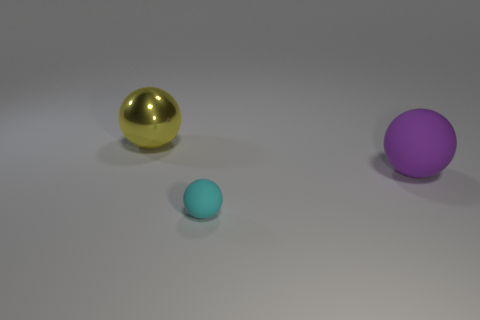The large metallic object has what shape?
Your response must be concise. Sphere. What number of things are both right of the big metal sphere and behind the tiny cyan rubber thing?
Provide a short and direct response. 1. Do the large rubber sphere and the big metal sphere have the same color?
Offer a very short reply. No. There is a cyan object that is the same shape as the yellow shiny object; what is it made of?
Ensure brevity in your answer.  Rubber. Is there any other thing that is made of the same material as the yellow sphere?
Provide a short and direct response. No. Are there the same number of small balls that are on the right side of the cyan rubber thing and cyan spheres that are to the left of the large yellow metal ball?
Ensure brevity in your answer.  Yes. Does the big purple object have the same material as the tiny thing?
Offer a terse response. Yes. How many brown things are either big rubber balls or big shiny things?
Provide a succinct answer. 0. What number of other purple rubber things are the same shape as the large purple matte object?
Provide a short and direct response. 0. What is the material of the tiny cyan ball?
Provide a succinct answer. Rubber. 